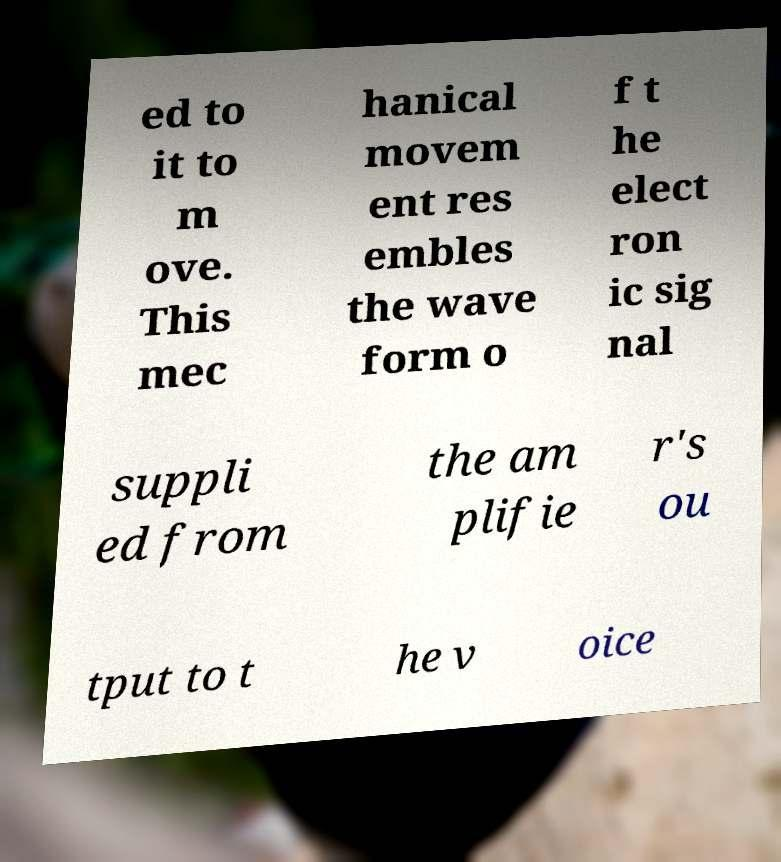Please identify and transcribe the text found in this image. ed to it to m ove. This mec hanical movem ent res embles the wave form o f t he elect ron ic sig nal suppli ed from the am plifie r's ou tput to t he v oice 